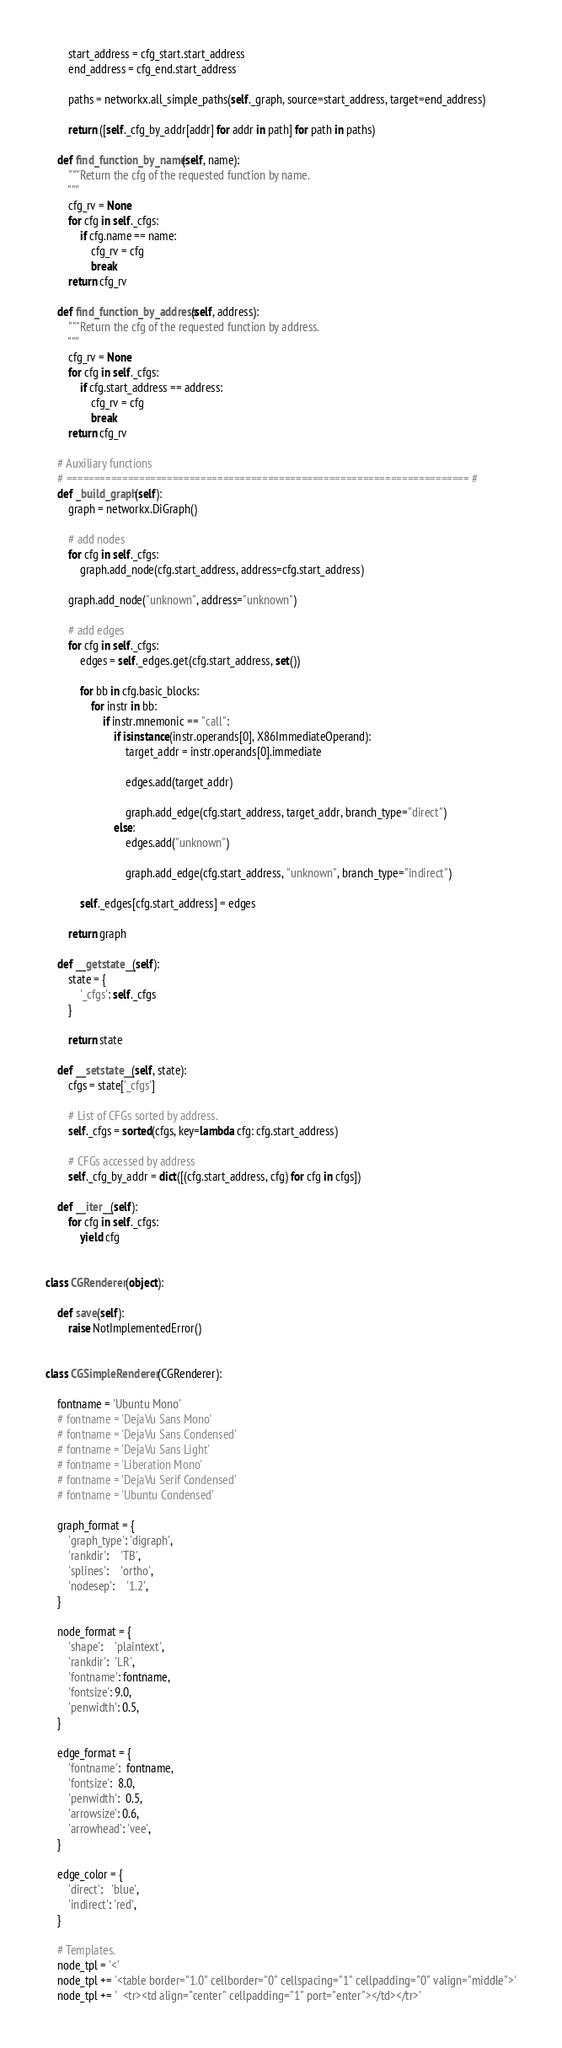Convert code to text. <code><loc_0><loc_0><loc_500><loc_500><_Python_>
        start_address = cfg_start.start_address
        end_address = cfg_end.start_address

        paths = networkx.all_simple_paths(self._graph, source=start_address, target=end_address)

        return ([self._cfg_by_addr[addr] for addr in path] for path in paths)

    def find_function_by_name(self, name):
        """Return the cfg of the requested function by name.
        """
        cfg_rv = None
        for cfg in self._cfgs:
            if cfg.name == name:
                cfg_rv = cfg
                break
        return cfg_rv

    def find_function_by_address(self, address):
        """Return the cfg of the requested function by address.
        """
        cfg_rv = None
        for cfg in self._cfgs:
            if cfg.start_address == address:
                cfg_rv = cfg
                break
        return cfg_rv

    # Auxiliary functions
    # ======================================================================== #
    def _build_graph(self):
        graph = networkx.DiGraph()

        # add nodes
        for cfg in self._cfgs:
            graph.add_node(cfg.start_address, address=cfg.start_address)

        graph.add_node("unknown", address="unknown")

        # add edges
        for cfg in self._cfgs:
            edges = self._edges.get(cfg.start_address, set())

            for bb in cfg.basic_blocks:
                for instr in bb:
                    if instr.mnemonic == "call":
                        if isinstance(instr.operands[0], X86ImmediateOperand):
                            target_addr = instr.operands[0].immediate

                            edges.add(target_addr)

                            graph.add_edge(cfg.start_address, target_addr, branch_type="direct")
                        else:
                            edges.add("unknown")

                            graph.add_edge(cfg.start_address, "unknown", branch_type="indirect")

            self._edges[cfg.start_address] = edges

        return graph

    def __getstate__(self):
        state = {
            '_cfgs': self._cfgs
        }

        return state

    def __setstate__(self, state):
        cfgs = state['_cfgs']

        # List of CFGs sorted by address.
        self._cfgs = sorted(cfgs, key=lambda cfg: cfg.start_address)

        # CFGs accessed by address
        self._cfg_by_addr = dict([(cfg.start_address, cfg) for cfg in cfgs])

    def __iter__(self):
        for cfg in self._cfgs:
            yield cfg


class CGRenderer(object):

    def save(self):
        raise NotImplementedError()


class CGSimpleRenderer(CGRenderer):

    fontname = 'Ubuntu Mono'
    # fontname = 'DejaVu Sans Mono'
    # fontname = 'DejaVu Sans Condensed'
    # fontname = 'DejaVu Sans Light'
    # fontname = 'Liberation Mono'
    # fontname = 'DejaVu Serif Condensed'
    # fontname = 'Ubuntu Condensed'

    graph_format = {
        'graph_type': 'digraph',
        'rankdir':    'TB',
        'splines':    'ortho',
        'nodesep':    '1.2',
    }

    node_format = {
        'shape':    'plaintext',
        'rankdir':  'LR',
        'fontname': fontname,
        'fontsize': 9.0,
        'penwidth': 0.5,
    }

    edge_format = {
        'fontname':  fontname,
        'fontsize':  8.0,
        'penwidth':  0.5,
        'arrowsize': 0.6,
        'arrowhead': 'vee',
    }

    edge_color = {
        'direct':   'blue',
        'indirect': 'red',
    }

    # Templates.
    node_tpl = '<'
    node_tpl += '<table border="1.0" cellborder="0" cellspacing="1" cellpadding="0" valign="middle">'
    node_tpl += '  <tr><td align="center" cellpadding="1" port="enter"></td></tr>'</code> 